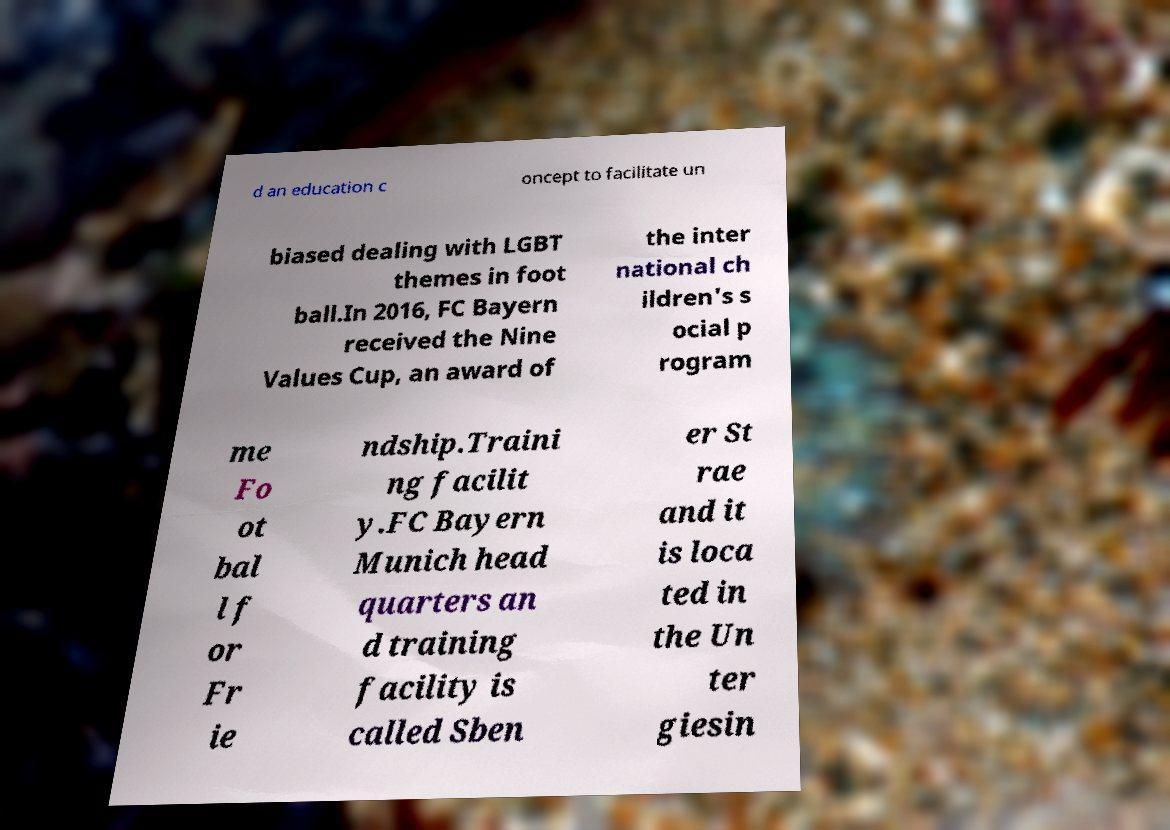What messages or text are displayed in this image? I need them in a readable, typed format. d an education c oncept to facilitate un biased dealing with LGBT themes in foot ball.In 2016, FC Bayern received the Nine Values Cup, an award of the inter national ch ildren's s ocial p rogram me Fo ot bal l f or Fr ie ndship.Traini ng facilit y.FC Bayern Munich head quarters an d training facility is called Sben er St rae and it is loca ted in the Un ter giesin 